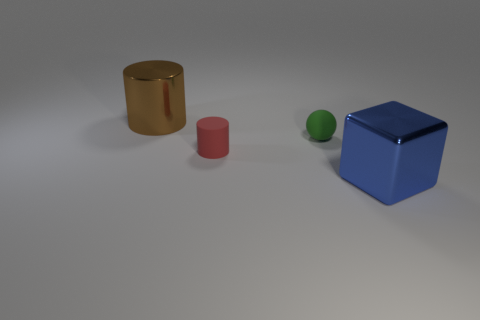There is a object that is in front of the small matte ball and behind the big blue metallic object; what material is it made of?
Provide a short and direct response. Rubber. Are there fewer metallic cylinders than purple matte objects?
Your response must be concise. No. There is a green matte object; is it the same shape as the big thing that is to the right of the ball?
Give a very brief answer. No. Does the metal object to the left of the blue shiny block have the same size as the red thing?
Ensure brevity in your answer.  No. The green rubber object that is the same size as the red matte thing is what shape?
Make the answer very short. Sphere. Does the tiny green matte object have the same shape as the red thing?
Offer a terse response. No. How many big brown objects are the same shape as the red rubber thing?
Offer a very short reply. 1. There is a big brown metallic cylinder; how many shiny cylinders are on the left side of it?
Your response must be concise. 0. Do the object that is left of the tiny red matte cylinder and the big cube have the same color?
Your answer should be compact. No. What number of metallic blocks are the same size as the blue shiny thing?
Make the answer very short. 0. 